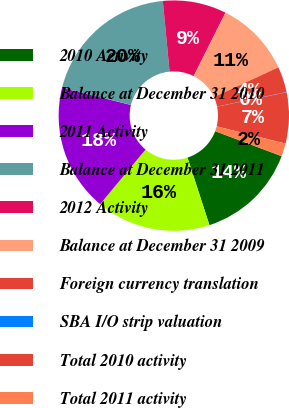<chart> <loc_0><loc_0><loc_500><loc_500><pie_chart><fcel>2010 Activity<fcel>Balance at December 31 2010<fcel>2011 Activity<fcel>Balance at December 31 2011<fcel>2012 Activity<fcel>Balance at December 31 2009<fcel>Foreign currency translation<fcel>SBA I/O strip valuation<fcel>Total 2010 activity<fcel>Total 2011 activity<nl><fcel>14.27%<fcel>16.05%<fcel>17.83%<fcel>19.6%<fcel>8.93%<fcel>10.71%<fcel>3.6%<fcel>0.04%<fcel>7.15%<fcel>1.82%<nl></chart> 